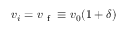Convert formula to latex. <formula><loc_0><loc_0><loc_500><loc_500>{ v _ { i } = v _ { f } \equiv v _ { 0 } ( 1 + \delta ) }</formula> 